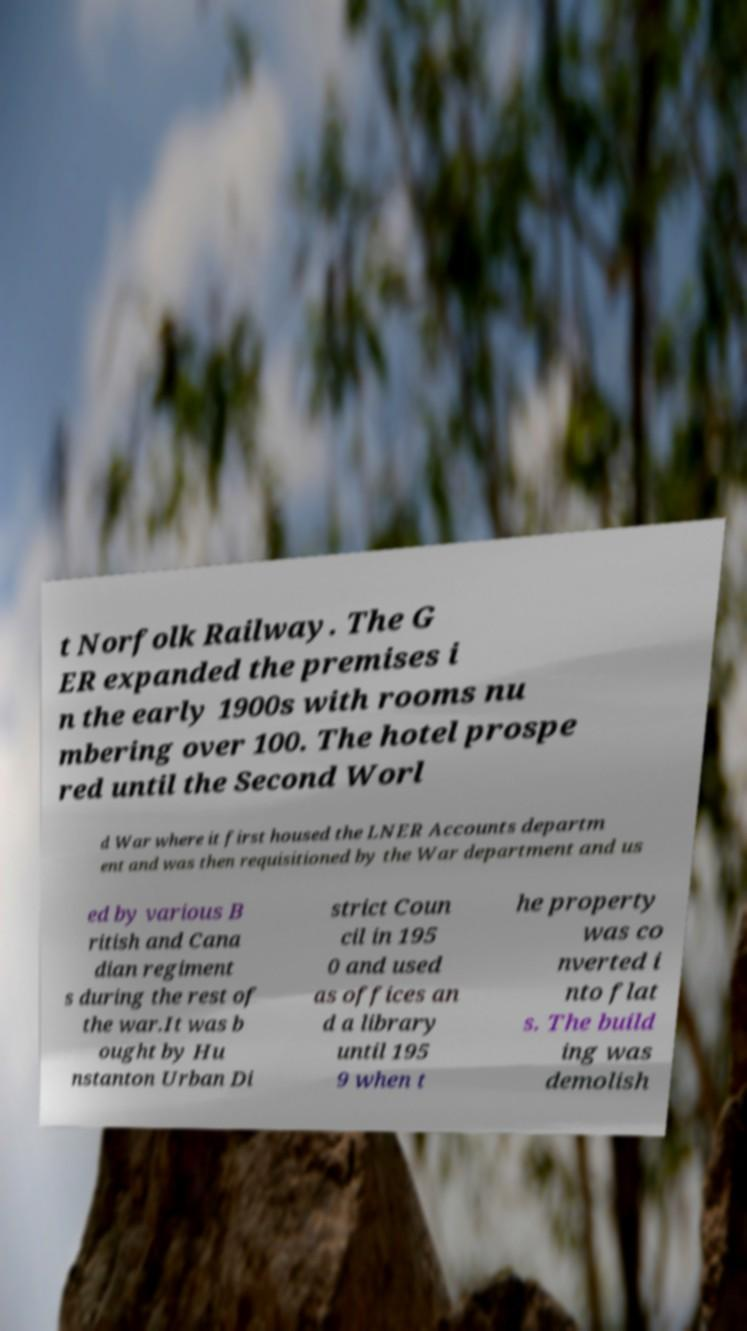What messages or text are displayed in this image? I need them in a readable, typed format. t Norfolk Railway. The G ER expanded the premises i n the early 1900s with rooms nu mbering over 100. The hotel prospe red until the Second Worl d War where it first housed the LNER Accounts departm ent and was then requisitioned by the War department and us ed by various B ritish and Cana dian regiment s during the rest of the war.It was b ought by Hu nstanton Urban Di strict Coun cil in 195 0 and used as offices an d a library until 195 9 when t he property was co nverted i nto flat s. The build ing was demolish 